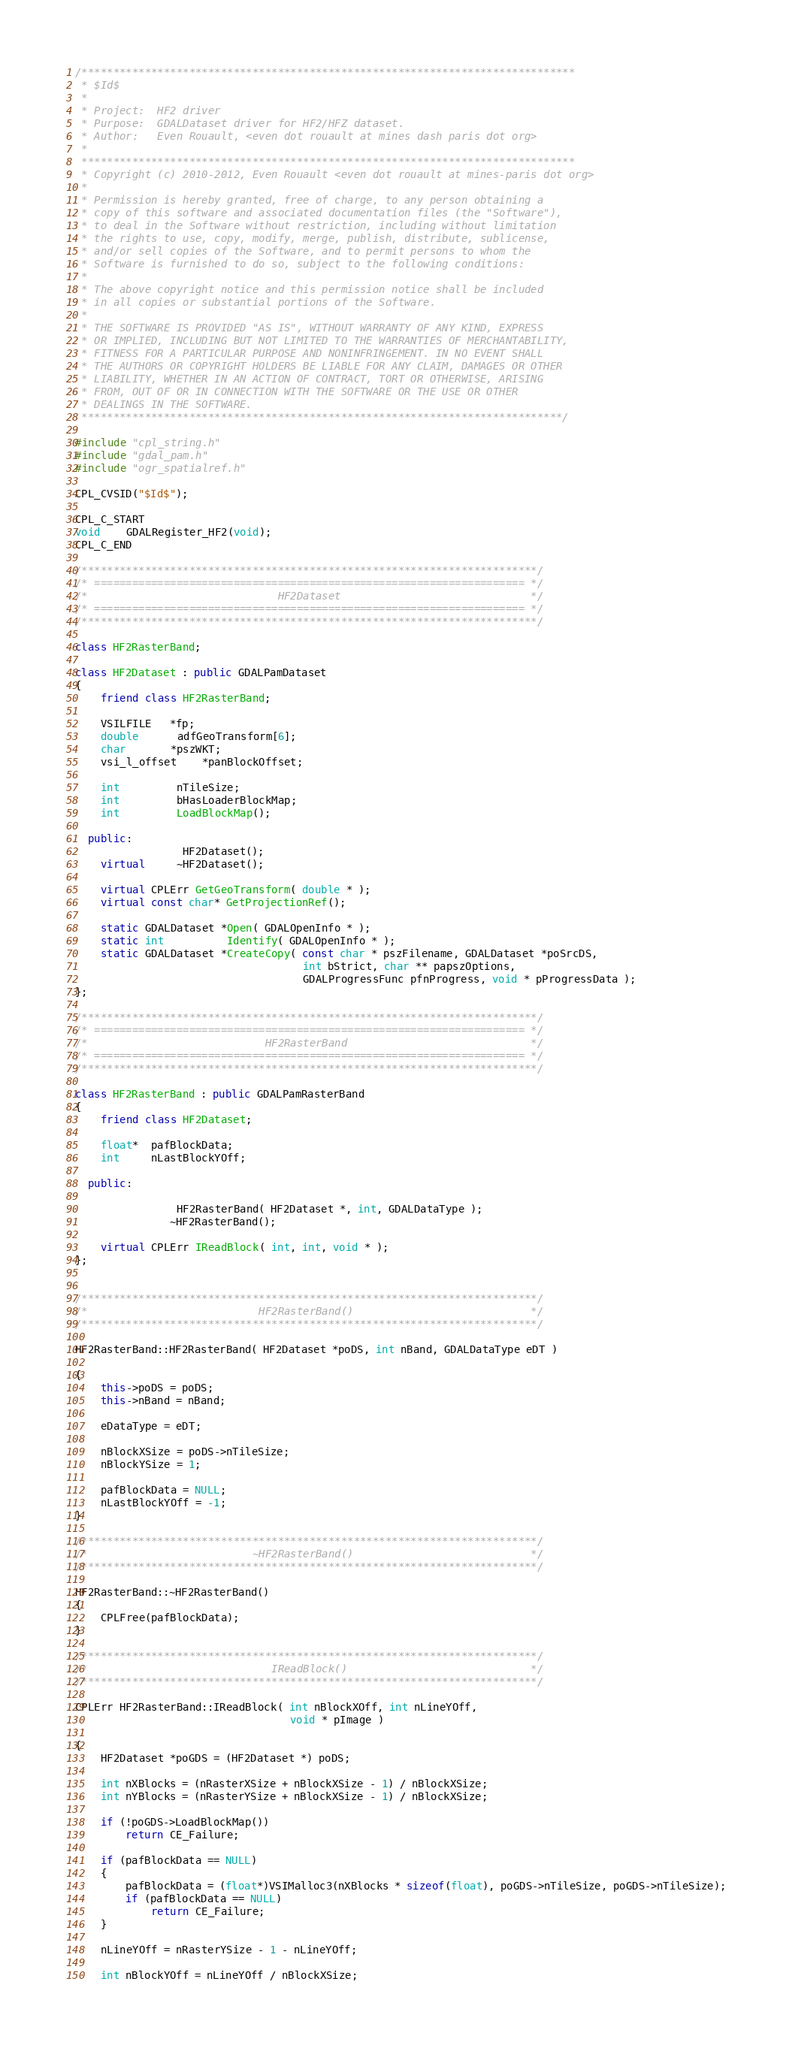<code> <loc_0><loc_0><loc_500><loc_500><_C++_>/******************************************************************************
 * $Id$
 *
 * Project:  HF2 driver
 * Purpose:  GDALDataset driver for HF2/HFZ dataset.
 * Author:   Even Rouault, <even dot rouault at mines dash paris dot org>
 *
 ******************************************************************************
 * Copyright (c) 2010-2012, Even Rouault <even dot rouault at mines-paris dot org>
 *
 * Permission is hereby granted, free of charge, to any person obtaining a
 * copy of this software and associated documentation files (the "Software"),
 * to deal in the Software without restriction, including without limitation
 * the rights to use, copy, modify, merge, publish, distribute, sublicense,
 * and/or sell copies of the Software, and to permit persons to whom the
 * Software is furnished to do so, subject to the following conditions:
 *
 * The above copyright notice and this permission notice shall be included
 * in all copies or substantial portions of the Software.
 *
 * THE SOFTWARE IS PROVIDED "AS IS", WITHOUT WARRANTY OF ANY KIND, EXPRESS
 * OR IMPLIED, INCLUDING BUT NOT LIMITED TO THE WARRANTIES OF MERCHANTABILITY,
 * FITNESS FOR A PARTICULAR PURPOSE AND NONINFRINGEMENT. IN NO EVENT SHALL
 * THE AUTHORS OR COPYRIGHT HOLDERS BE LIABLE FOR ANY CLAIM, DAMAGES OR OTHER
 * LIABILITY, WHETHER IN AN ACTION OF CONTRACT, TORT OR OTHERWISE, ARISING
 * FROM, OUT OF OR IN CONNECTION WITH THE SOFTWARE OR THE USE OR OTHER
 * DEALINGS IN THE SOFTWARE.
 ****************************************************************************/

#include "cpl_string.h"
#include "gdal_pam.h"
#include "ogr_spatialref.h"

CPL_CVSID("$Id$");

CPL_C_START
void    GDALRegister_HF2(void);
CPL_C_END

/************************************************************************/
/* ==================================================================== */
/*                              HF2Dataset                              */
/* ==================================================================== */
/************************************************************************/

class HF2RasterBand;

class HF2Dataset : public GDALPamDataset
{
    friend class HF2RasterBand;
    
    VSILFILE   *fp;
    double      adfGeoTransform[6];
    char       *pszWKT;
    vsi_l_offset    *panBlockOffset;

    int         nTileSize;
    int         bHasLoaderBlockMap;
    int         LoadBlockMap();

  public:
                 HF2Dataset();
    virtual     ~HF2Dataset();
    
    virtual CPLErr GetGeoTransform( double * );
    virtual const char* GetProjectionRef();
    
    static GDALDataset *Open( GDALOpenInfo * );
    static int          Identify( GDALOpenInfo * );
    static GDALDataset *CreateCopy( const char * pszFilename, GDALDataset *poSrcDS, 
                                    int bStrict, char ** papszOptions, 
                                    GDALProgressFunc pfnProgress, void * pProgressData );
};

/************************************************************************/
/* ==================================================================== */
/*                            HF2RasterBand                             */
/* ==================================================================== */
/************************************************************************/

class HF2RasterBand : public GDALPamRasterBand
{
    friend class HF2Dataset;

    float*  pafBlockData;
    int     nLastBlockYOff;

  public:

                HF2RasterBand( HF2Dataset *, int, GDALDataType );
               ~HF2RasterBand();

    virtual CPLErr IReadBlock( int, int, void * );
};


/************************************************************************/
/*                           HF2RasterBand()                            */
/************************************************************************/

HF2RasterBand::HF2RasterBand( HF2Dataset *poDS, int nBand, GDALDataType eDT )

{
    this->poDS = poDS;
    this->nBand = nBand;

    eDataType = eDT;

    nBlockXSize = poDS->nTileSize;
    nBlockYSize = 1;

    pafBlockData = NULL;
    nLastBlockYOff = -1;
}

/************************************************************************/
/*                          ~HF2RasterBand()                            */
/************************************************************************/

HF2RasterBand::~HF2RasterBand()
{
    CPLFree(pafBlockData);
}

/************************************************************************/
/*                             IReadBlock()                             */
/************************************************************************/

CPLErr HF2RasterBand::IReadBlock( int nBlockXOff, int nLineYOff,
                                  void * pImage )

{
    HF2Dataset *poGDS = (HF2Dataset *) poDS;

    int nXBlocks = (nRasterXSize + nBlockXSize - 1) / nBlockXSize;
    int nYBlocks = (nRasterYSize + nBlockXSize - 1) / nBlockXSize;
    
    if (!poGDS->LoadBlockMap())
        return CE_Failure;
    
    if (pafBlockData == NULL)
    {
        pafBlockData = (float*)VSIMalloc3(nXBlocks * sizeof(float), poGDS->nTileSize, poGDS->nTileSize);
        if (pafBlockData == NULL)
            return CE_Failure;
    }
    
    nLineYOff = nRasterYSize - 1 - nLineYOff;

    int nBlockYOff = nLineYOff / nBlockXSize;</code> 